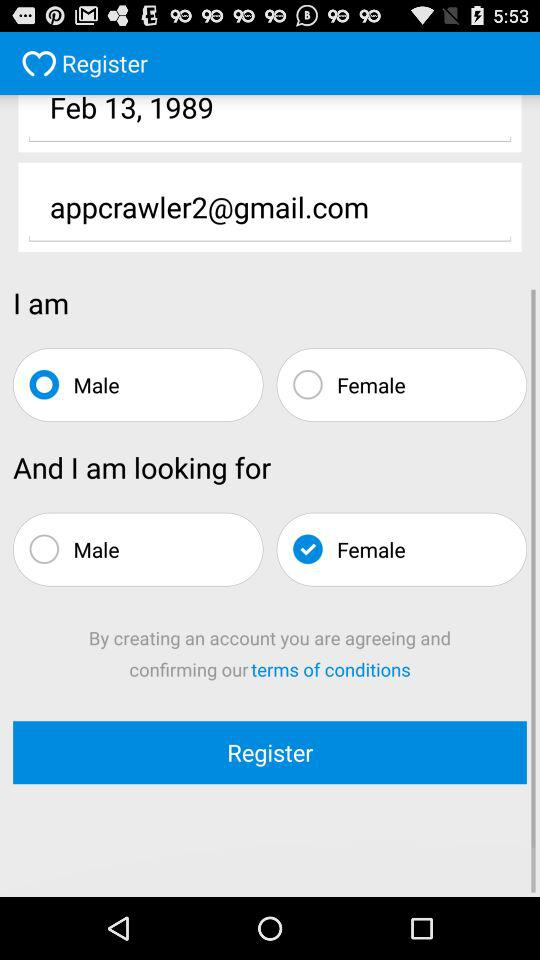What is the name of the user? The name of the user is "Raphael". 